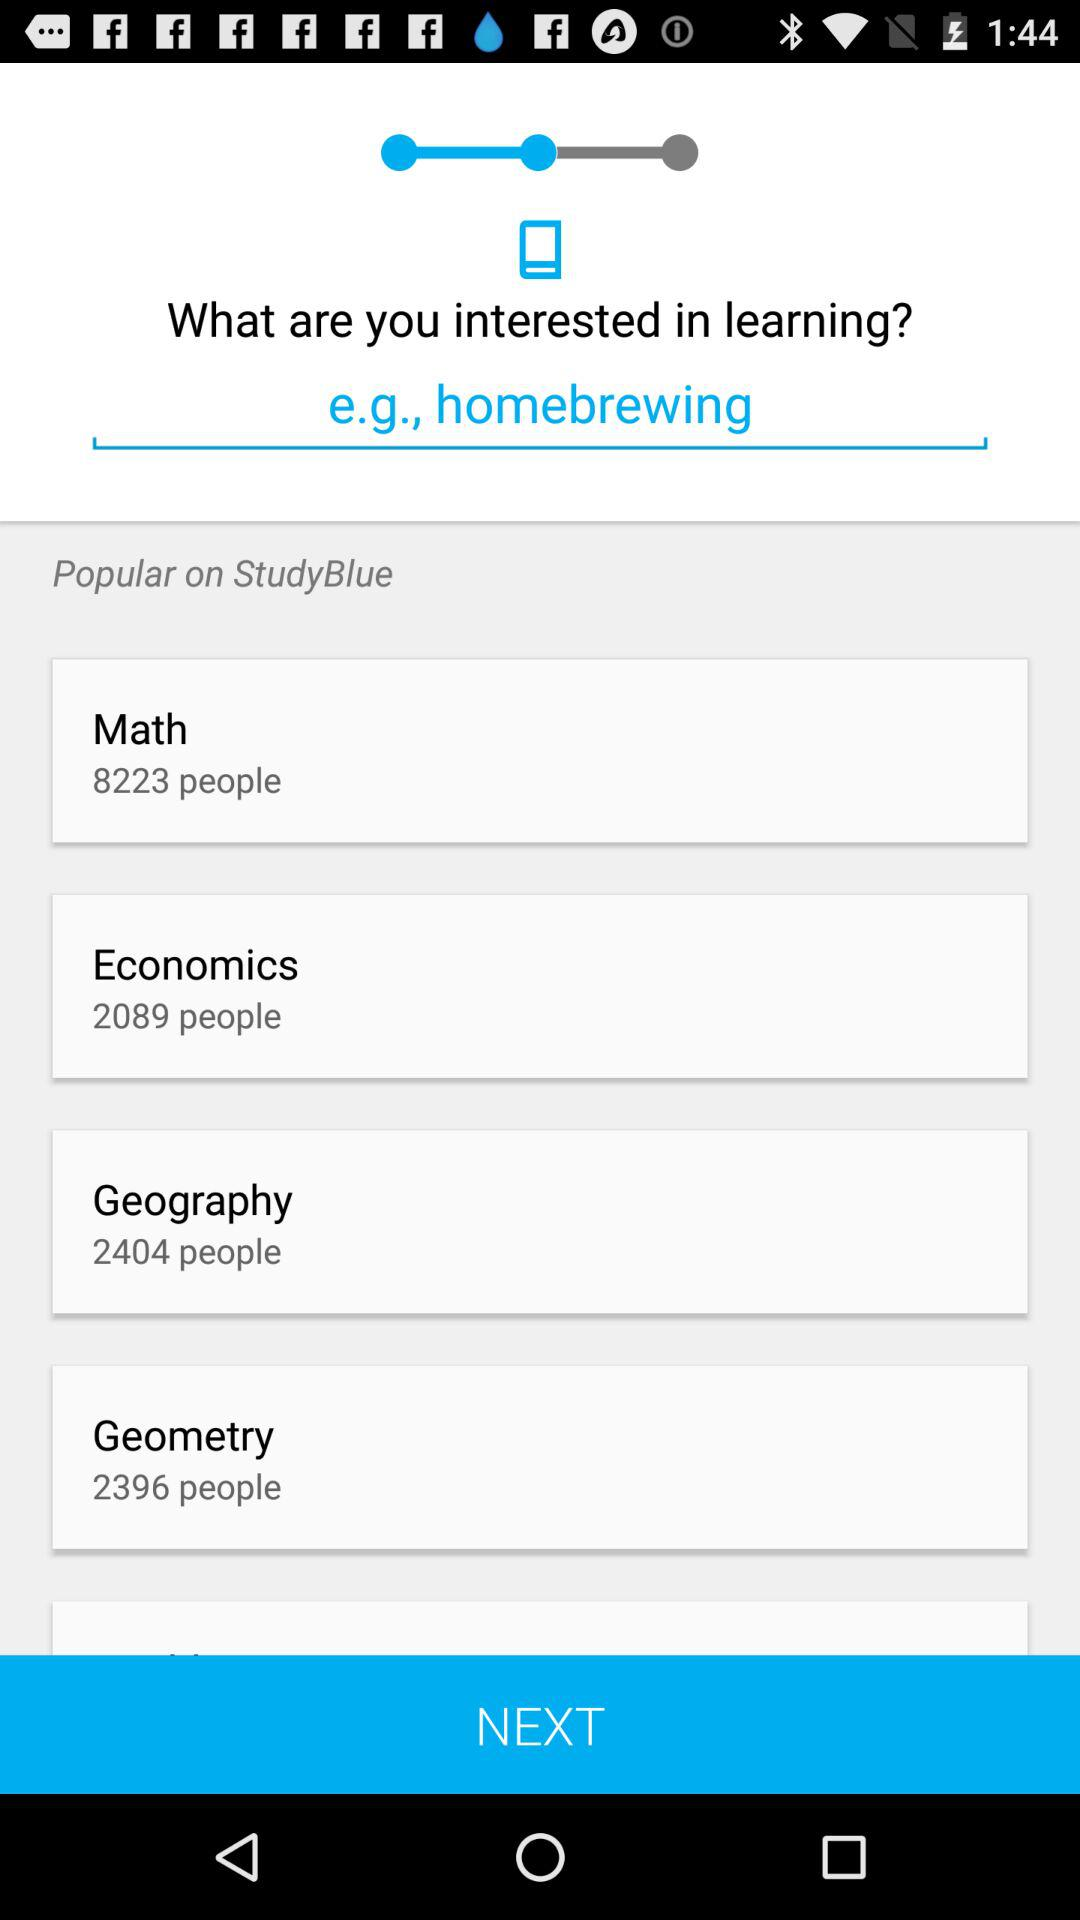What is the count of people for Math? The count of people for Math is 8223. 